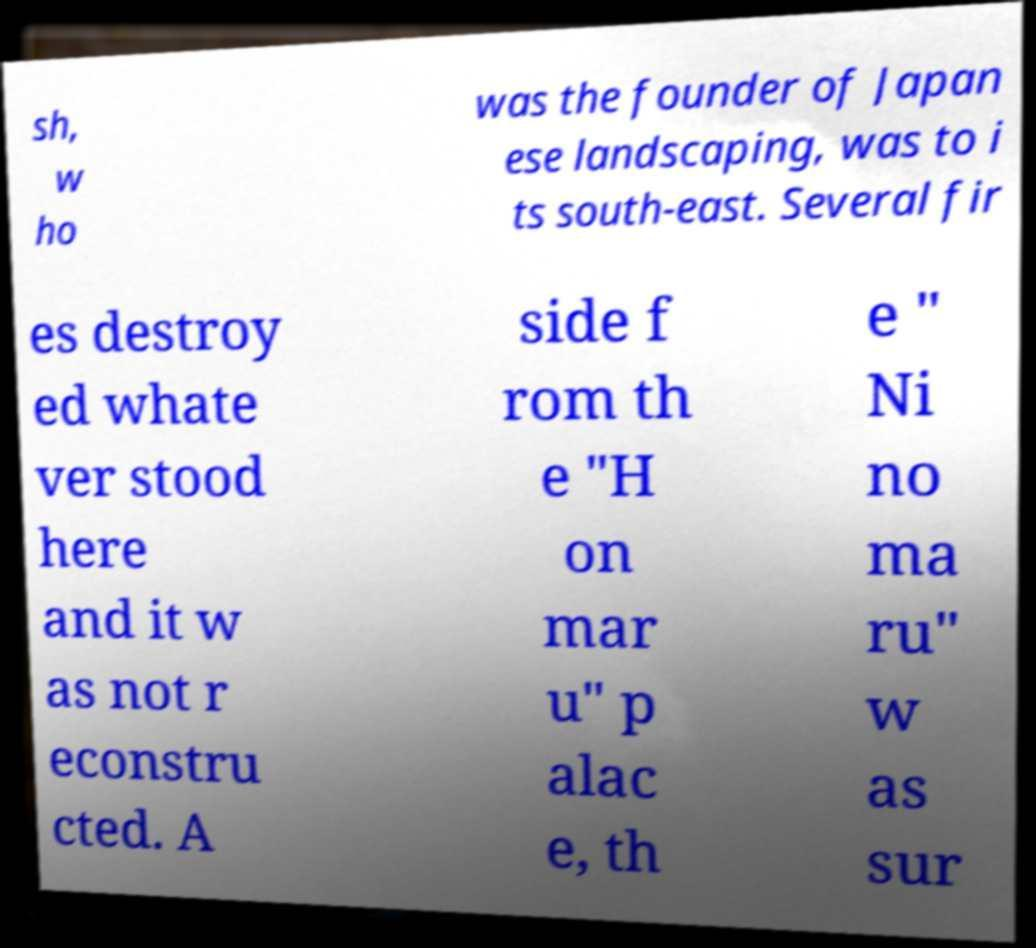Could you extract and type out the text from this image? sh, w ho was the founder of Japan ese landscaping, was to i ts south-east. Several fir es destroy ed whate ver stood here and it w as not r econstru cted. A side f rom th e "H on mar u" p alac e, th e " Ni no ma ru" w as sur 